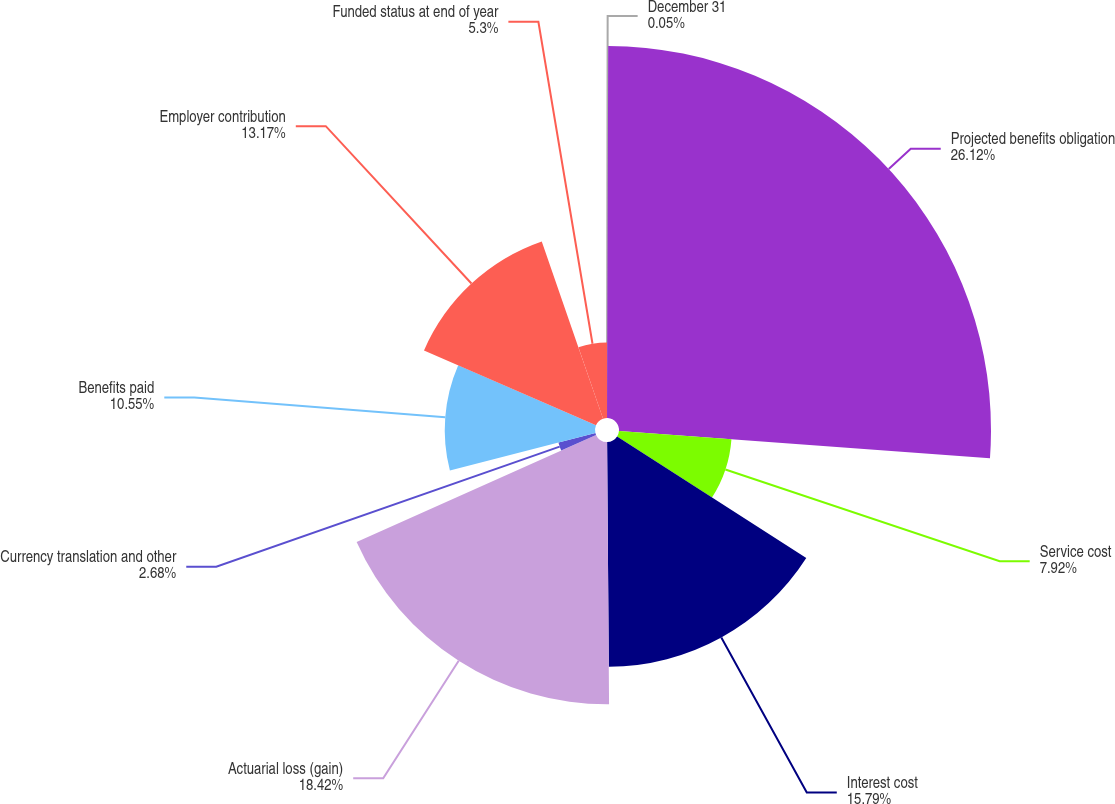<chart> <loc_0><loc_0><loc_500><loc_500><pie_chart><fcel>December 31<fcel>Projected benefits obligation<fcel>Service cost<fcel>Interest cost<fcel>Actuarial loss (gain)<fcel>Currency translation and other<fcel>Benefits paid<fcel>Employer contribution<fcel>Funded status at end of year<nl><fcel>0.05%<fcel>26.12%<fcel>7.92%<fcel>15.79%<fcel>18.42%<fcel>2.68%<fcel>10.55%<fcel>13.17%<fcel>5.3%<nl></chart> 